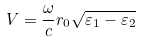<formula> <loc_0><loc_0><loc_500><loc_500>V = \frac { \omega } { c } r _ { 0 } \sqrt { \varepsilon _ { 1 } - \varepsilon _ { 2 } }</formula> 